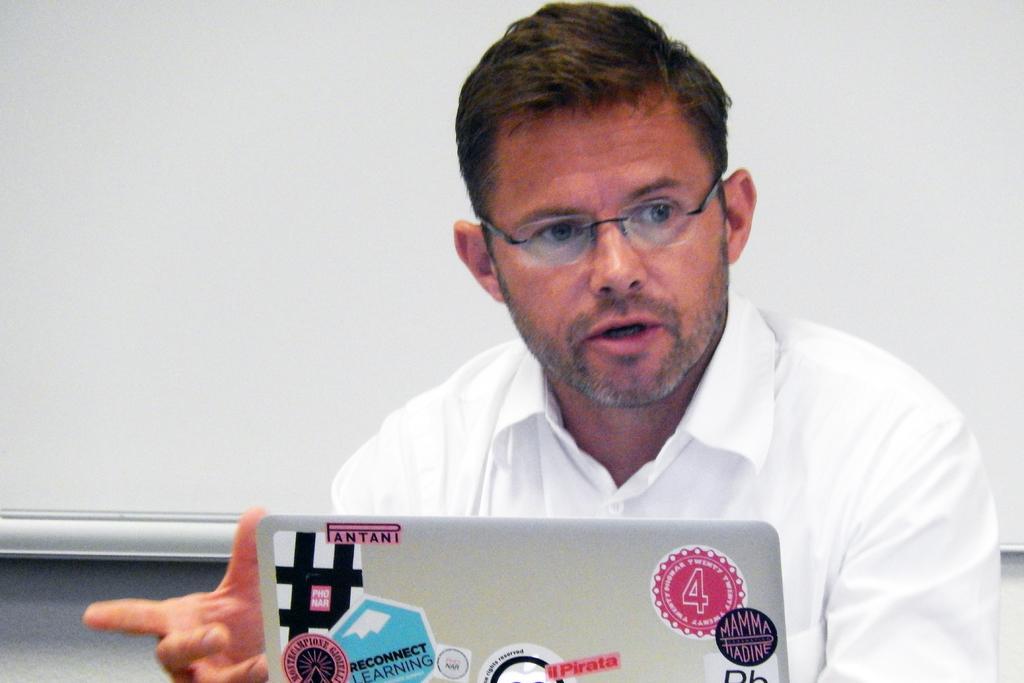Please provide a concise description of this image. In this picture there is a person sitting on the chair and in front there is a laptop. 